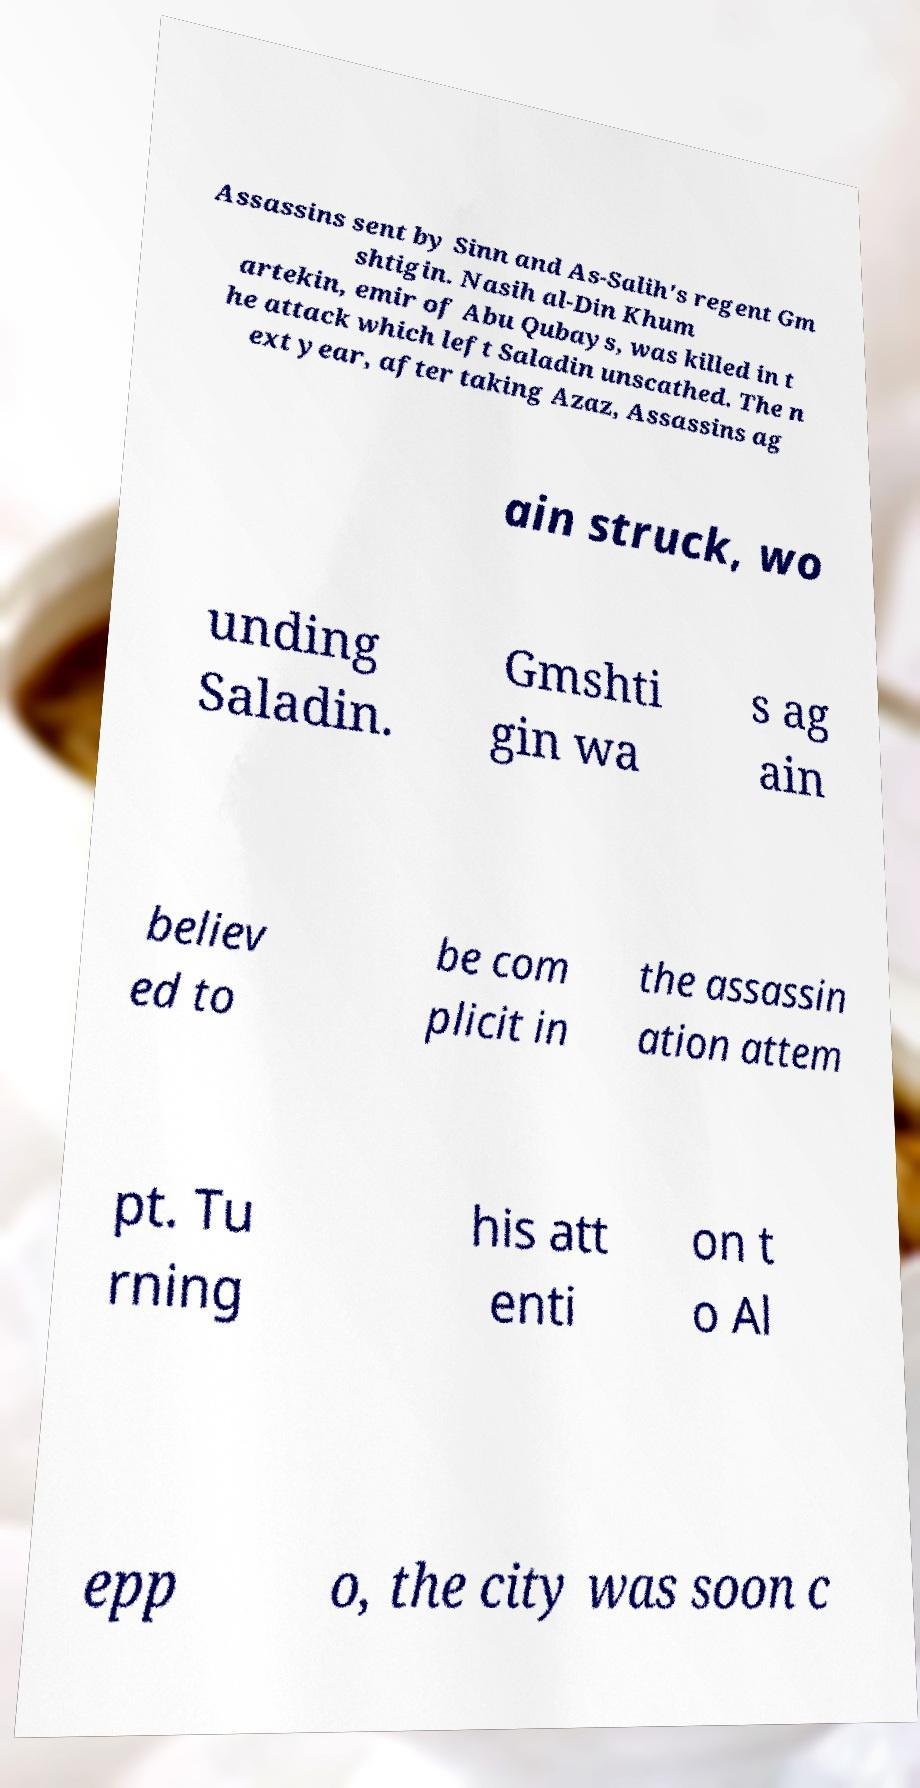I need the written content from this picture converted into text. Can you do that? Assassins sent by Sinn and As-Salih's regent Gm shtigin. Nasih al-Din Khum artekin, emir of Abu Qubays, was killed in t he attack which left Saladin unscathed. The n ext year, after taking Azaz, Assassins ag ain struck, wo unding Saladin. Gmshti gin wa s ag ain believ ed to be com plicit in the assassin ation attem pt. Tu rning his att enti on t o Al epp o, the city was soon c 